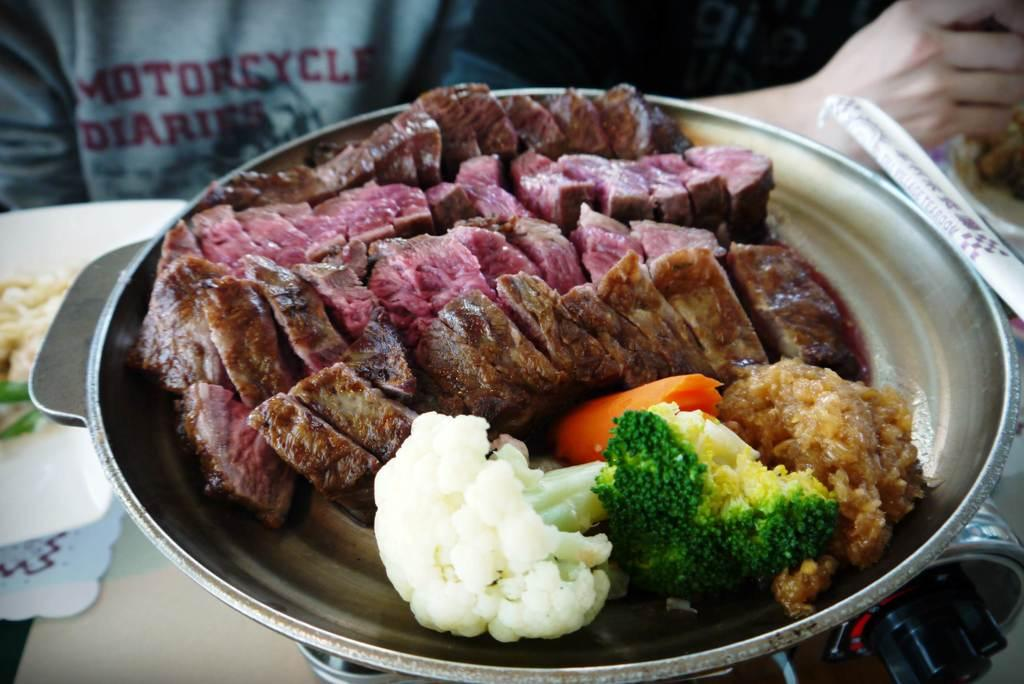What is in the bowl that is visible in the image? There is a bowl with food in the image. Who does the bowl belong to? The bowl belongs to a person. Can you describe any body parts visible in the image? There is a person's hand visible in the top right of the image. How many cats are sitting on the edge of the bowl in the image? There are no cats present in the image. 